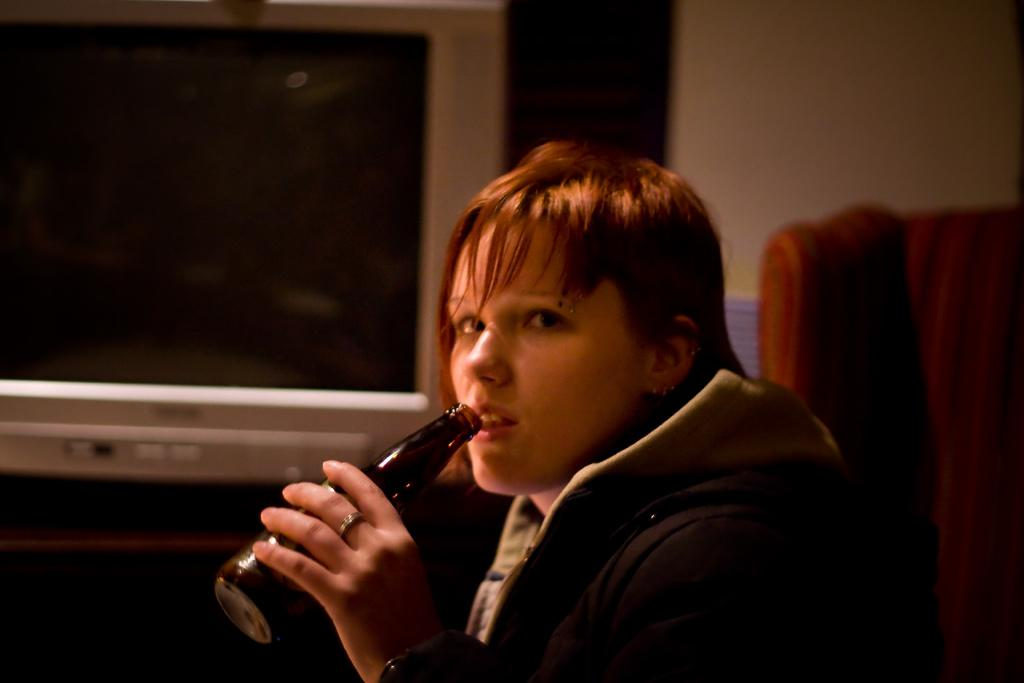Who is present in the image? There is a woman in the image. What is the woman wearing? The woman is wearing a jacket. What is the woman holding in her hand? The woman is holding a bottle in her hand. What can be seen in the background of the image? There is a television, a table, a wall, and a chair in the background of the image. What type of fairies can be seen flying around the woman in the image? There are no fairies present in the image. What type of sand can be seen on the floor in the image? There is no sand visible in the image; it appears to be an indoor setting with a floor covering. 